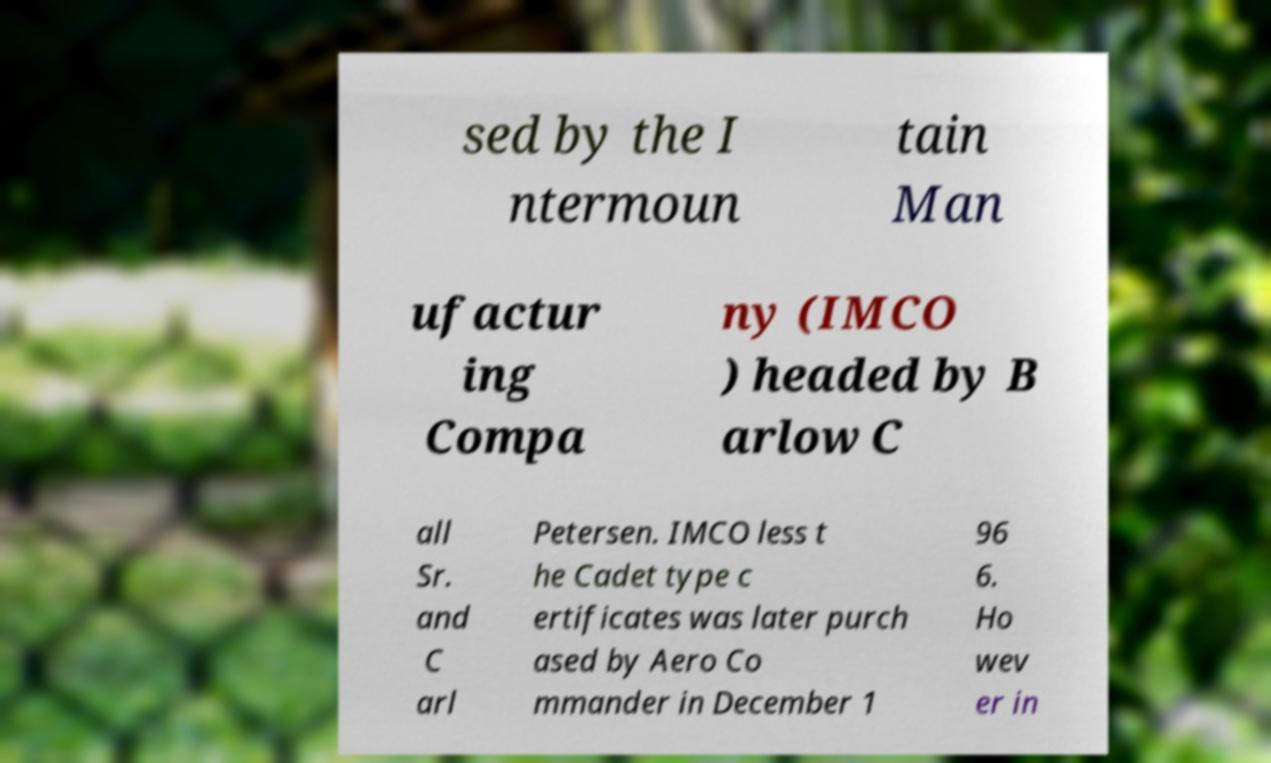Please identify and transcribe the text found in this image. sed by the I ntermoun tain Man ufactur ing Compa ny (IMCO ) headed by B arlow C all Sr. and C arl Petersen. IMCO less t he Cadet type c ertificates was later purch ased by Aero Co mmander in December 1 96 6. Ho wev er in 